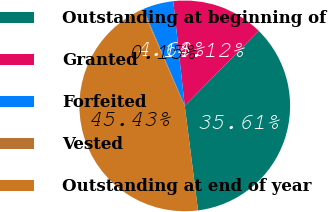Convert chart. <chart><loc_0><loc_0><loc_500><loc_500><pie_chart><fcel>Outstanding at beginning of<fcel>Granted<fcel>Forfeited<fcel>Vested<fcel>Outstanding at end of year<nl><fcel>35.61%<fcel>14.12%<fcel>4.68%<fcel>0.15%<fcel>45.43%<nl></chart> 